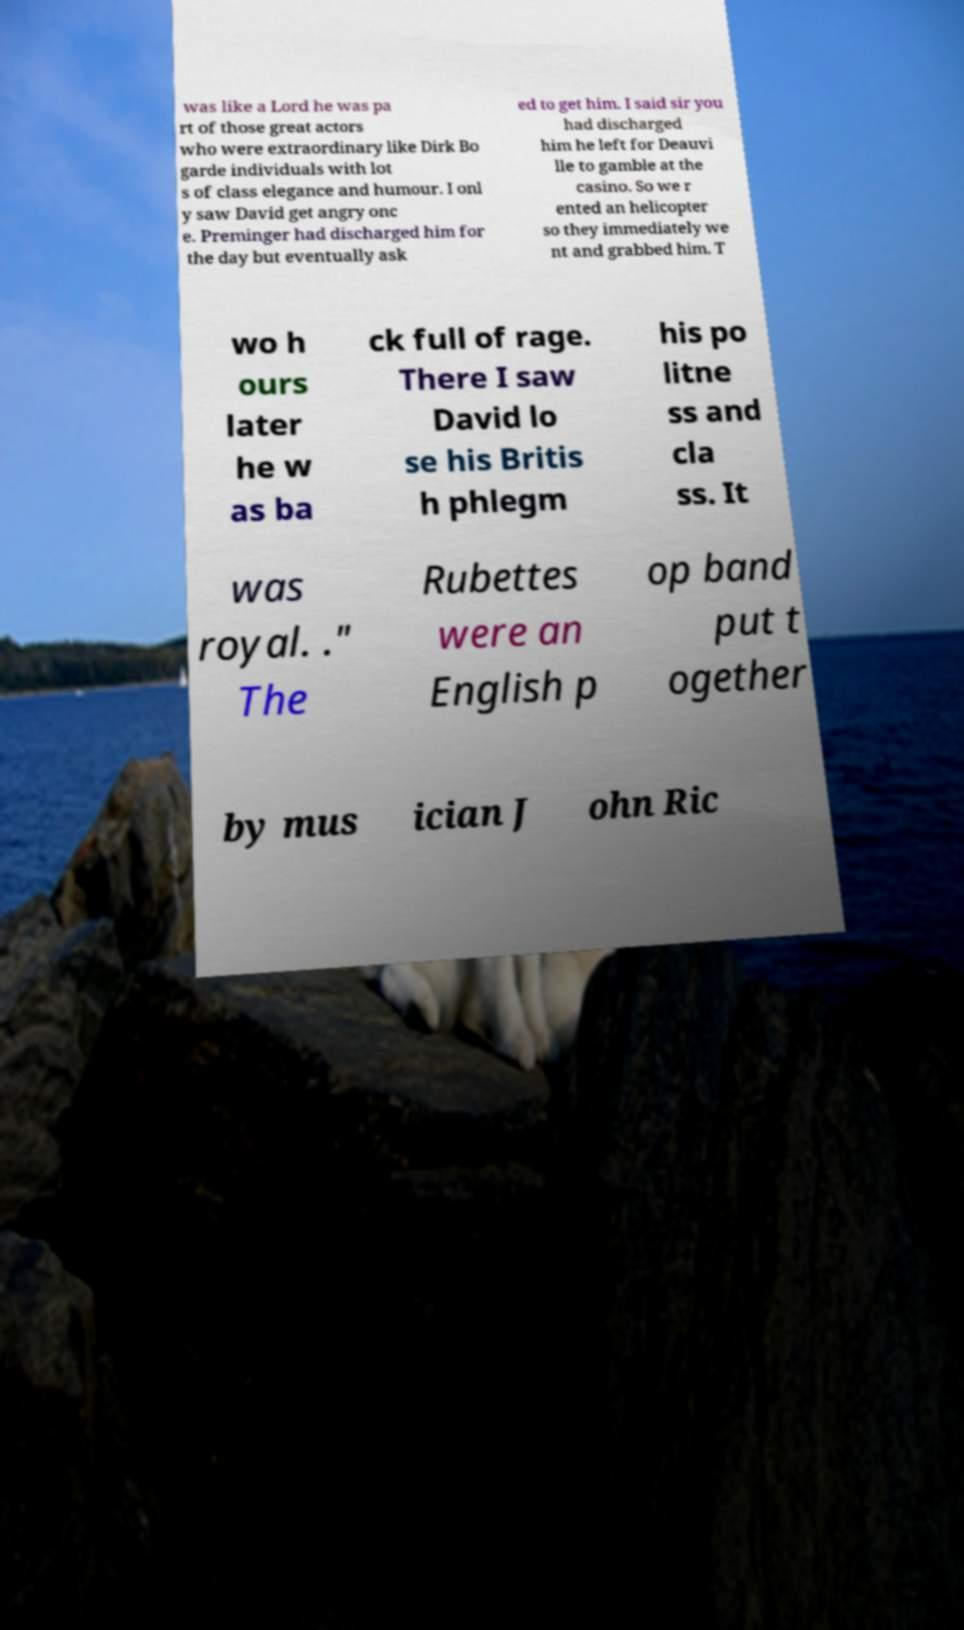For documentation purposes, I need the text within this image transcribed. Could you provide that? was like a Lord he was pa rt of those great actors who were extraordinary like Dirk Bo garde individuals with lot s of class elegance and humour. I onl y saw David get angry onc e. Preminger had discharged him for the day but eventually ask ed to get him. I said sir you had discharged him he left for Deauvi lle to gamble at the casino. So we r ented an helicopter so they immediately we nt and grabbed him. T wo h ours later he w as ba ck full of rage. There I saw David lo se his Britis h phlegm his po litne ss and cla ss. It was royal. ." The Rubettes were an English p op band put t ogether by mus ician J ohn Ric 